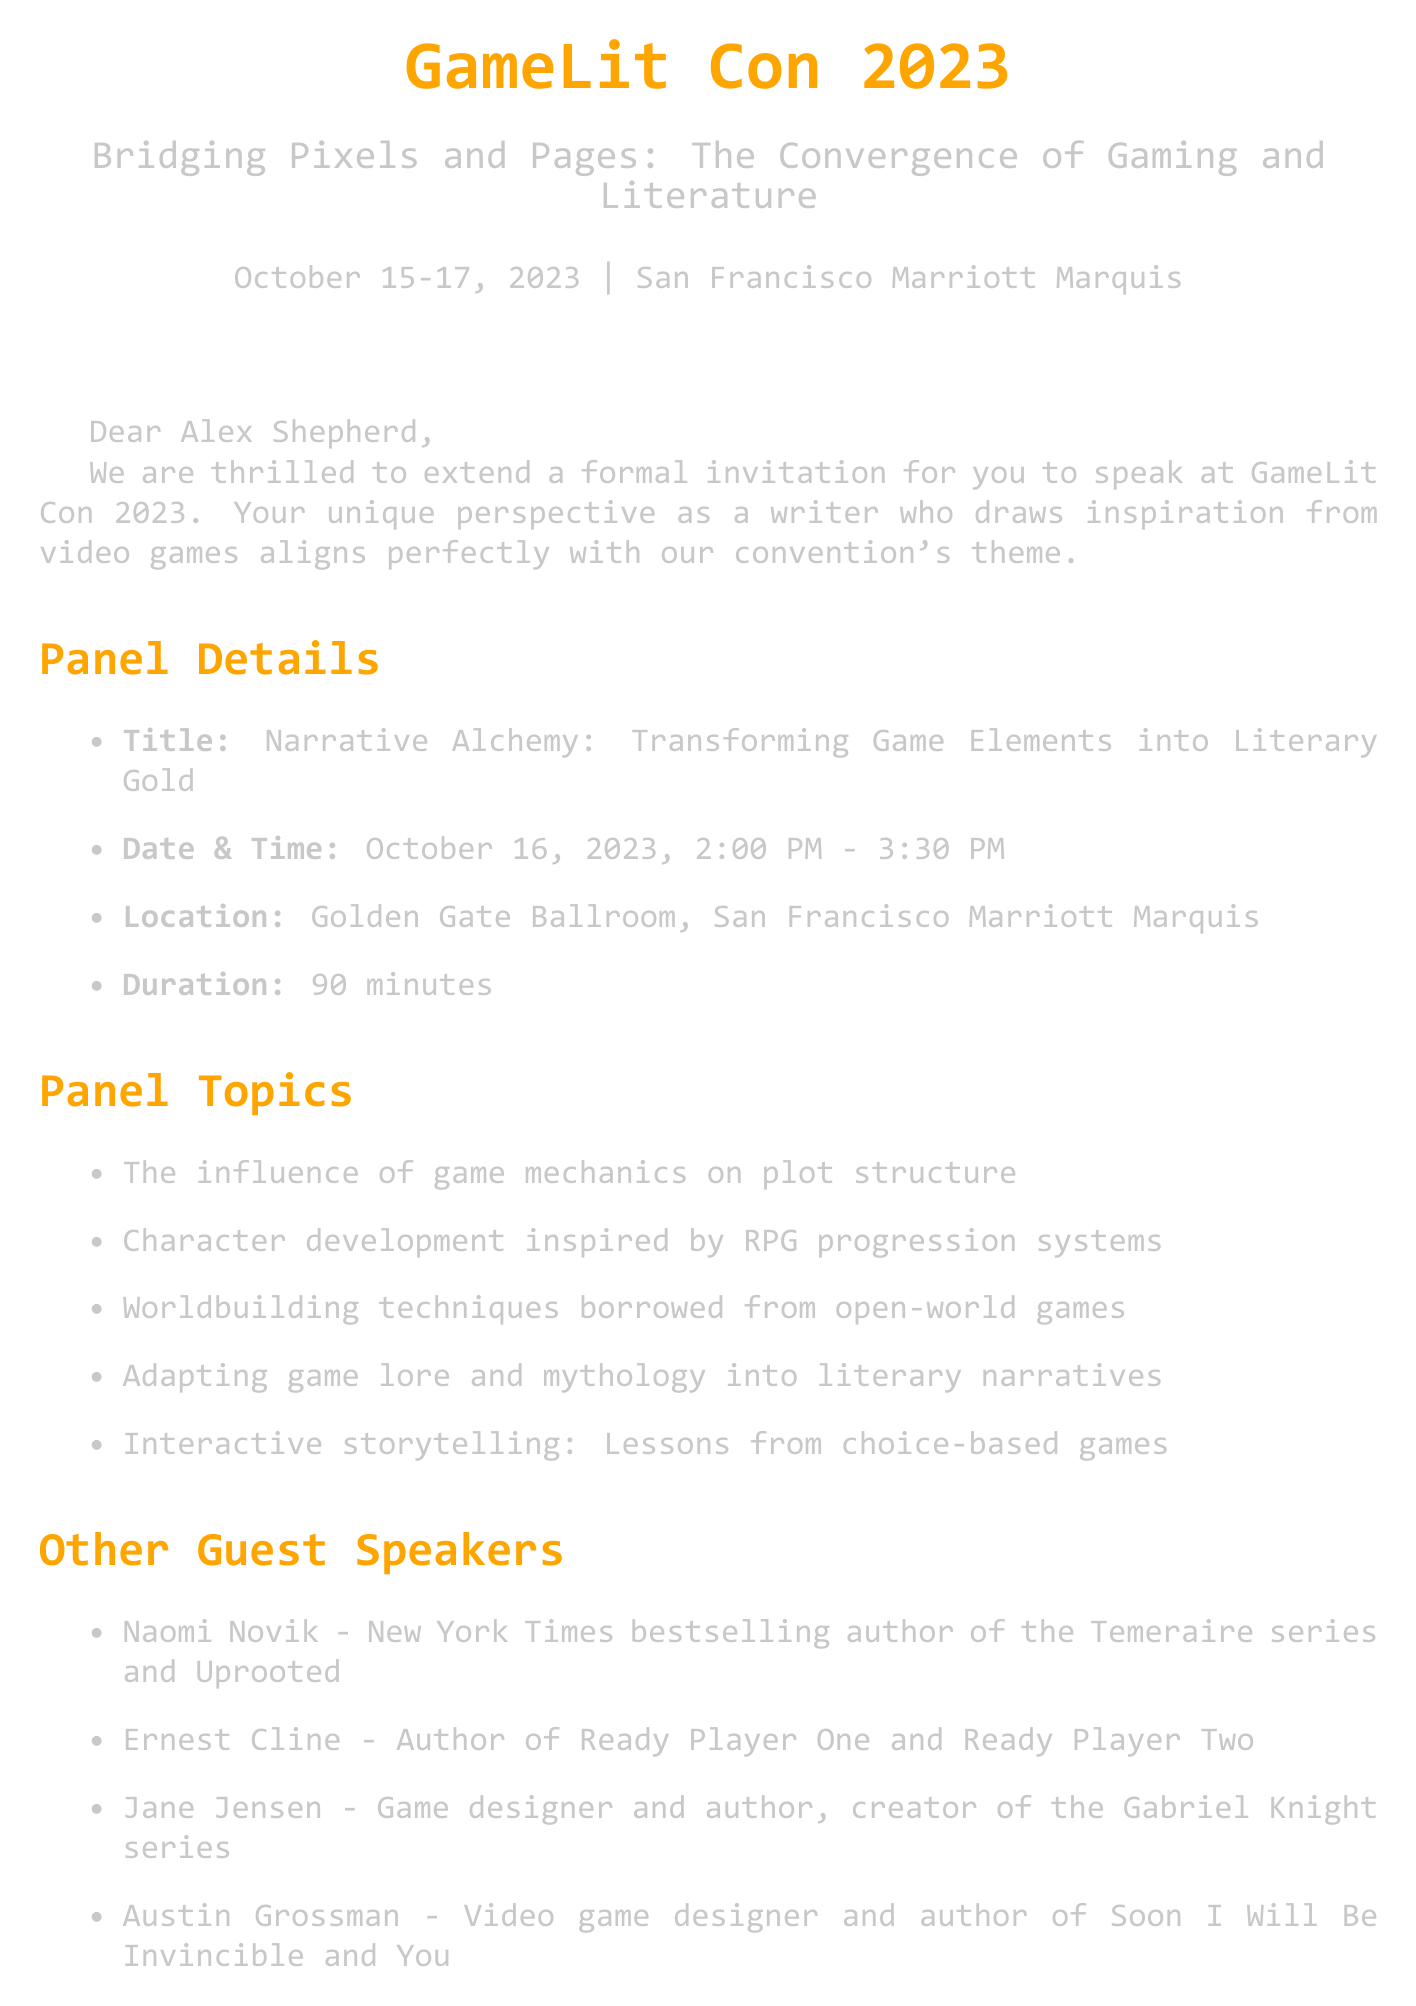what is the name of the convention? The convention is named "GameLit Con 2023."
Answer: GameLit Con 2023 what is the theme of the convention? The theme of the convention is highlighted in the document.
Answer: Bridging Pixels and Pages: The Convergence of Gaming and Literature when is the panel scheduled? The panel is scheduled for October 16, 2023.
Answer: October 16, 2023 who is invited to speak at the convention? The invitation is addressed to a specific individual.
Answer: Alex Shepherd what is the honorarium amount offered? The honorarium amount is specified in the invitation.
Answer: $1,500 how long is the panel duration? The duration of the panel is explicitly stated.
Answer: 90 minutes which room will the panel be held in? The room for the panel is mentioned in the document.
Answer: Golden Gate Ballroom what type of room was arranged for accommodations? The document specifies the type of room provided for the stay.
Answer: Deluxe King Room how many guest speakers are listed? The number of guest speakers can be counted in the document.
Answer: Four 